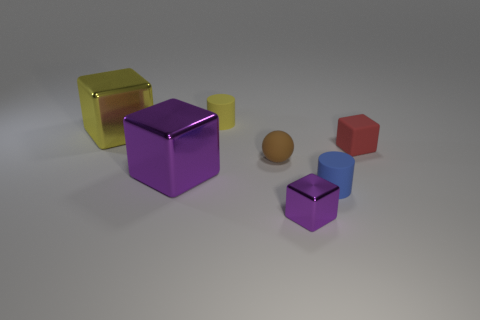Add 2 yellow metallic cubes. How many objects exist? 9 Subtract all spheres. How many objects are left? 6 Add 6 large cyan metal spheres. How many large cyan metal spheres exist? 6 Subtract 0 green cylinders. How many objects are left? 7 Subtract all large matte cylinders. Subtract all tiny yellow matte objects. How many objects are left? 6 Add 4 blue objects. How many blue objects are left? 5 